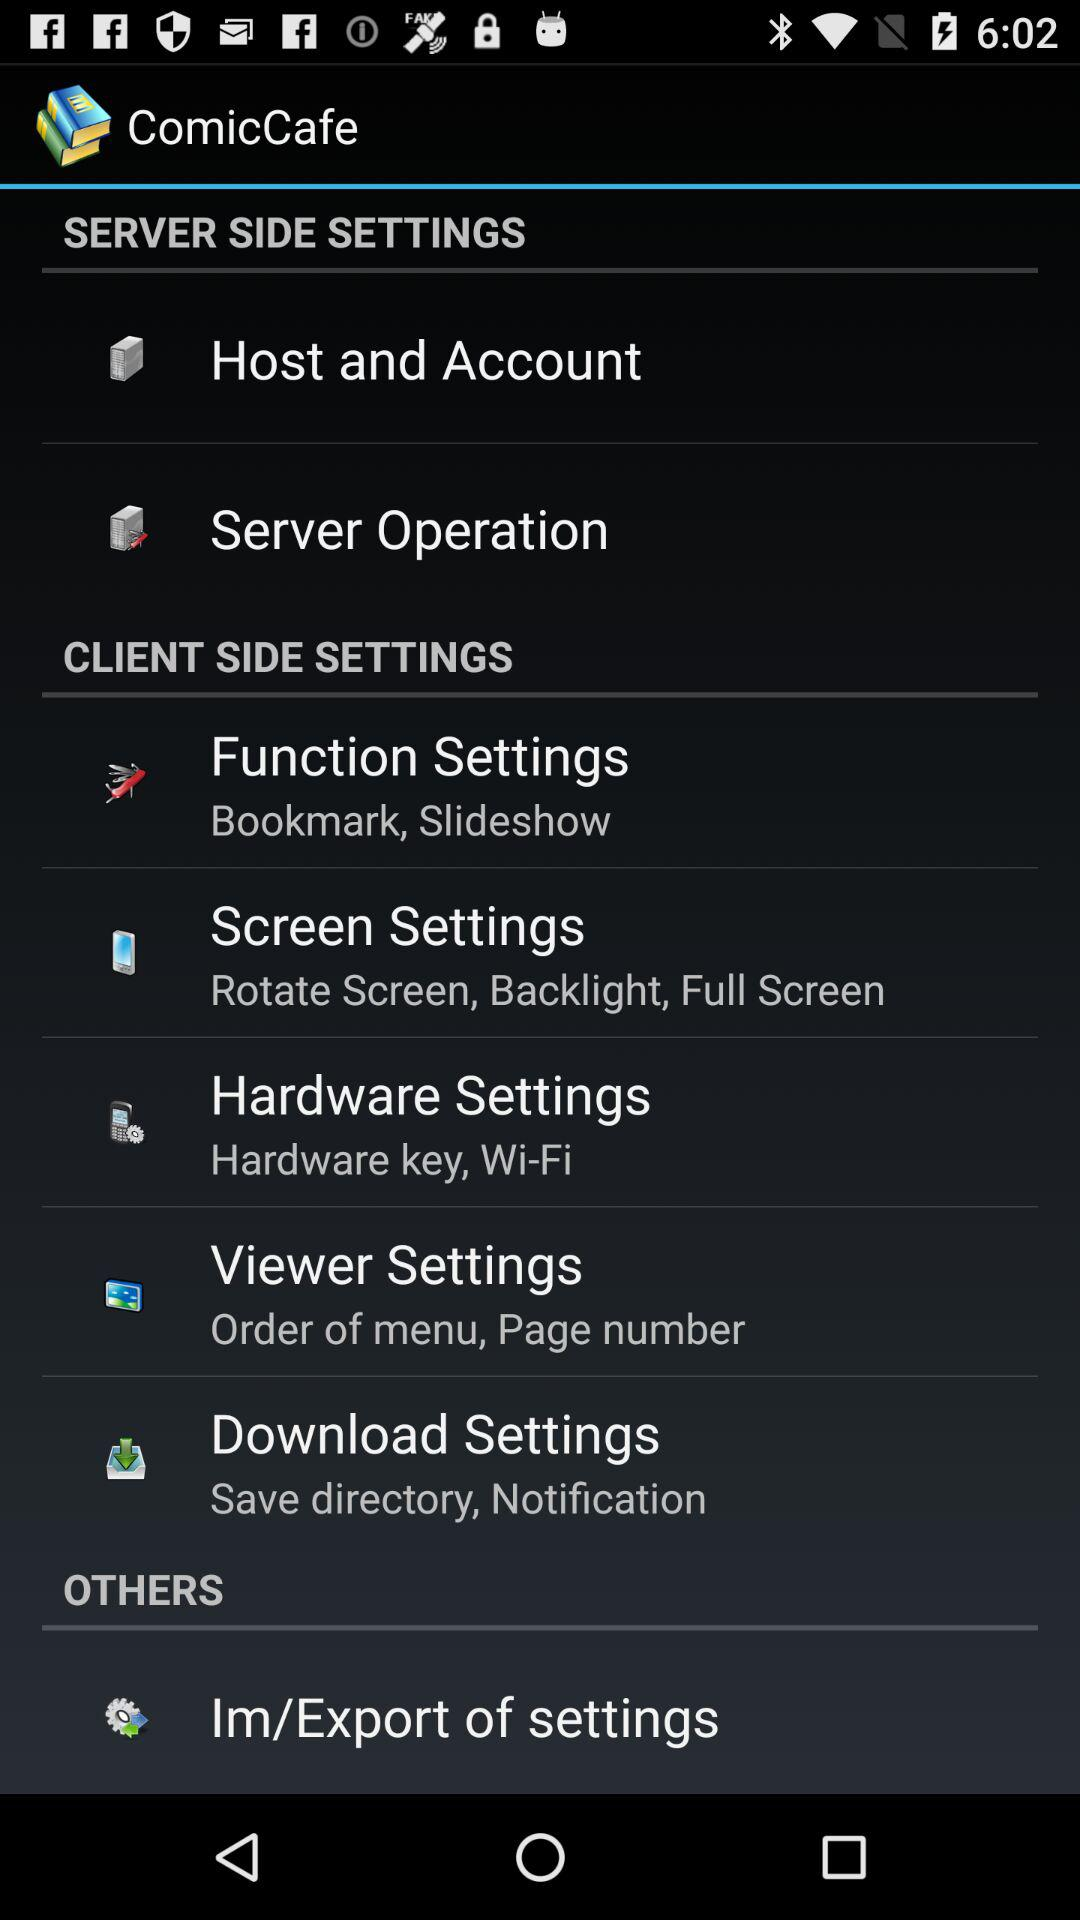What is the application name? The application name is "ComicCafe". 